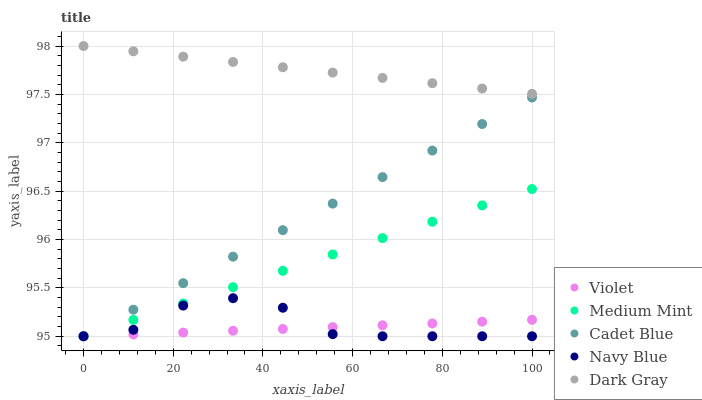Does Violet have the minimum area under the curve?
Answer yes or no. Yes. Does Dark Gray have the maximum area under the curve?
Answer yes or no. Yes. Does Navy Blue have the minimum area under the curve?
Answer yes or no. No. Does Navy Blue have the maximum area under the curve?
Answer yes or no. No. Is Dark Gray the smoothest?
Answer yes or no. Yes. Is Navy Blue the roughest?
Answer yes or no. Yes. Is Cadet Blue the smoothest?
Answer yes or no. No. Is Cadet Blue the roughest?
Answer yes or no. No. Does Medium Mint have the lowest value?
Answer yes or no. Yes. Does Dark Gray have the lowest value?
Answer yes or no. No. Does Dark Gray have the highest value?
Answer yes or no. Yes. Does Navy Blue have the highest value?
Answer yes or no. No. Is Cadet Blue less than Dark Gray?
Answer yes or no. Yes. Is Dark Gray greater than Violet?
Answer yes or no. Yes. Does Cadet Blue intersect Navy Blue?
Answer yes or no. Yes. Is Cadet Blue less than Navy Blue?
Answer yes or no. No. Is Cadet Blue greater than Navy Blue?
Answer yes or no. No. Does Cadet Blue intersect Dark Gray?
Answer yes or no. No. 